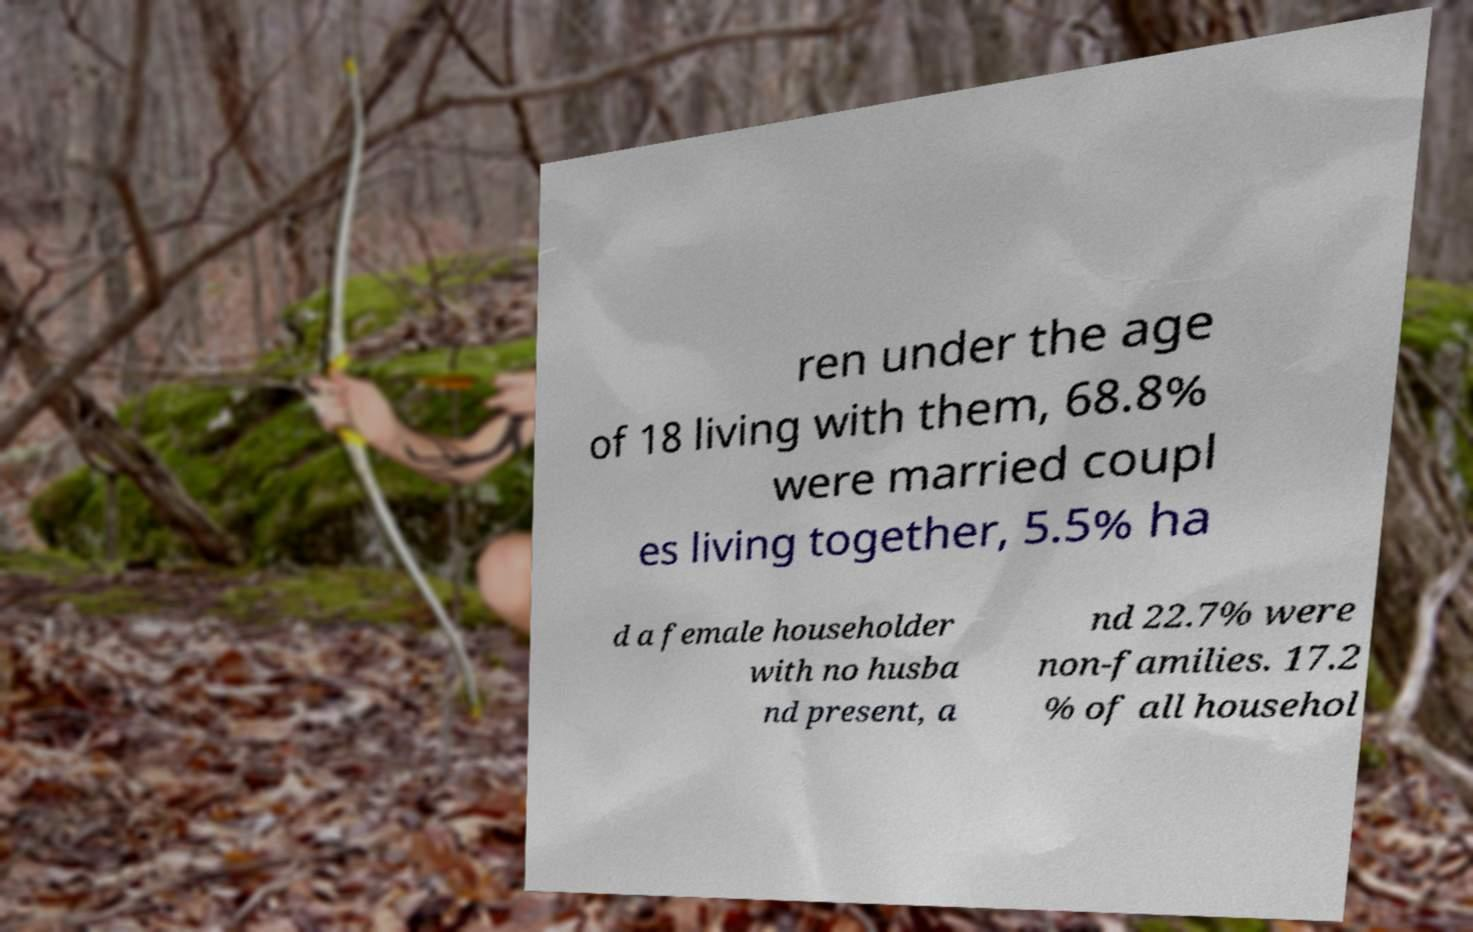There's text embedded in this image that I need extracted. Can you transcribe it verbatim? ren under the age of 18 living with them, 68.8% were married coupl es living together, 5.5% ha d a female householder with no husba nd present, a nd 22.7% were non-families. 17.2 % of all househol 